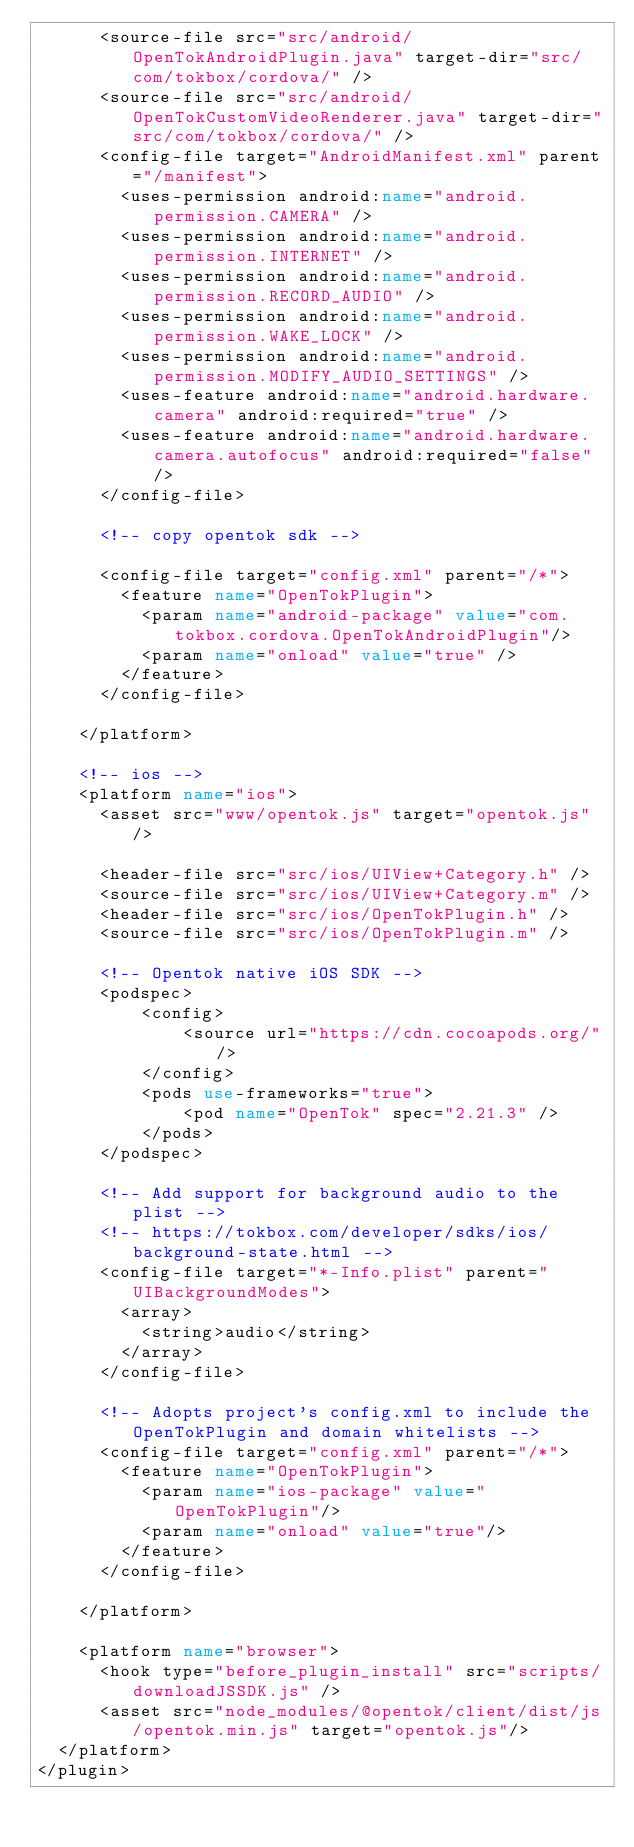Convert code to text. <code><loc_0><loc_0><loc_500><loc_500><_XML_>  	  <source-file src="src/android/OpenTokAndroidPlugin.java" target-dir="src/com/tokbox/cordova/" />
      <source-file src="src/android/OpenTokCustomVideoRenderer.java" target-dir="src/com/tokbox/cordova/" />
      <config-file target="AndroidManifest.xml" parent="/manifest">
        <uses-permission android:name="android.permission.CAMERA" />
        <uses-permission android:name="android.permission.INTERNET" />
        <uses-permission android:name="android.permission.RECORD_AUDIO" />
        <uses-permission android:name="android.permission.WAKE_LOCK" />
        <uses-permission android:name="android.permission.MODIFY_AUDIO_SETTINGS" />
        <uses-feature android:name="android.hardware.camera" android:required="true" />
        <uses-feature android:name="android.hardware.camera.autofocus" android:required="false" />
      </config-file>

      <!-- copy opentok sdk -->

      <config-file target="config.xml" parent="/*">
        <feature name="OpenTokPlugin">
          <param name="android-package" value="com.tokbox.cordova.OpenTokAndroidPlugin"/>
          <param name="onload" value="true" />
        </feature>
      </config-file>  
      
    </platform>

    <!-- ios -->
    <platform name="ios">
      <asset src="www/opentok.js" target="opentok.js" />

      <header-file src="src/ios/UIView+Category.h" />
      <source-file src="src/ios/UIView+Category.m" />
      <header-file src="src/ios/OpenTokPlugin.h" />
      <source-file src="src/ios/OpenTokPlugin.m" />

      <!-- Opentok native iOS SDK -->
      <podspec>
          <config>
              <source url="https://cdn.cocoapods.org/"/>
          </config>
          <pods use-frameworks="true">
              <pod name="OpenTok" spec="2.21.3" />
          </pods>
      </podspec>

      <!-- Add support for background audio to the plist -->
      <!-- https://tokbox.com/developer/sdks/ios/background-state.html -->
      <config-file target="*-Info.plist" parent="UIBackgroundModes">
        <array>
          <string>audio</string>
        </array>
      </config-file>

      <!-- Adopts project's config.xml to include the OpenTokPlugin and domain whitelists -->
      <config-file target="config.xml" parent="/*">
        <feature name="OpenTokPlugin">
          <param name="ios-package" value="OpenTokPlugin"/>
          <param name="onload" value="true"/>
        </feature>
      </config-file>

    </platform>

    <platform name="browser">
      <hook type="before_plugin_install" src="scripts/downloadJSSDK.js" />
      <asset src="node_modules/@opentok/client/dist/js/opentok.min.js" target="opentok.js"/>
  </platform>
</plugin>
</code> 